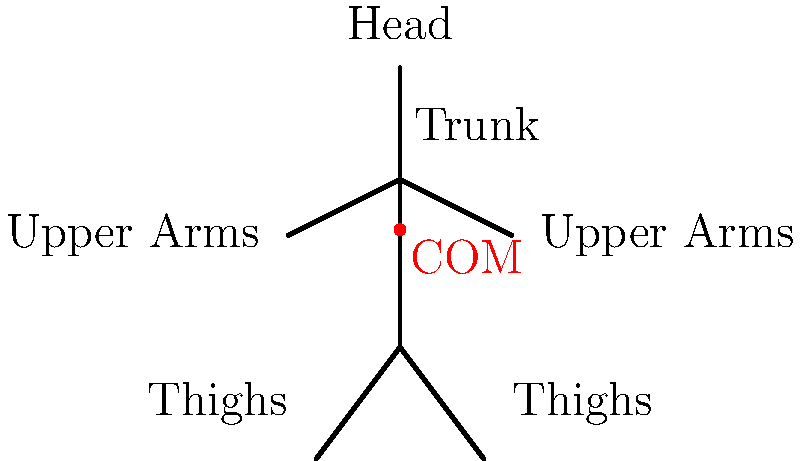As a career coach designing a program for biomechanics professionals, you need to assess their understanding of center of mass calculations. Consider the stick figure shown, representing a person standing with arms slightly bent. Given that the relative masses of body segments are: head (7%), trunk (43%), upper arms (2.7% each), and thighs (10% each), calculate the vertical position of the center of mass (COM) as a percentage of total body height. Assume the COM of each segment is at its midpoint. To calculate the vertical position of the center of mass, we'll use the segmental analysis method:

1. Identify the vertical positions of each segment's COM:
   - Head: 97.5% of height
   - Trunk: 70% of height
   - Upper Arms: 50% of height
   - Thighs: 20% of height

2. Calculate the weighted average using the given mass percentages:

   $$ \text{COM}_{\text{vertical}} = \frac{\sum (\text{mass}_i \times \text{position}_i)}{\sum \text{mass}_i} $$

3. Plug in the values:

   $$ \begin{align}
   \text{COM}_{\text{vertical}} &= \frac{(7\% \times 97.5\%) + (43\% \times 70\%) + (2.7\% \times 50\% \times 2) + (10\% \times 20\% \times 2)}{7\% + 43\% + 2.7\% \times 2 + 10\% \times 2} \\[10pt]
   &= \frac{6.825\% + 30.1\% + 2.7\% + 4\%}{75.4\%} \\[10pt]
   &= \frac{43.625\%}{75.4\%} \\[10pt]
   &\approx 57.86\%
   \end{align} $$

4. Convert to a percentage of total body height:
   $57.86\% \times 100\% \approx 57.86\%$
Answer: 57.86% of total body height 